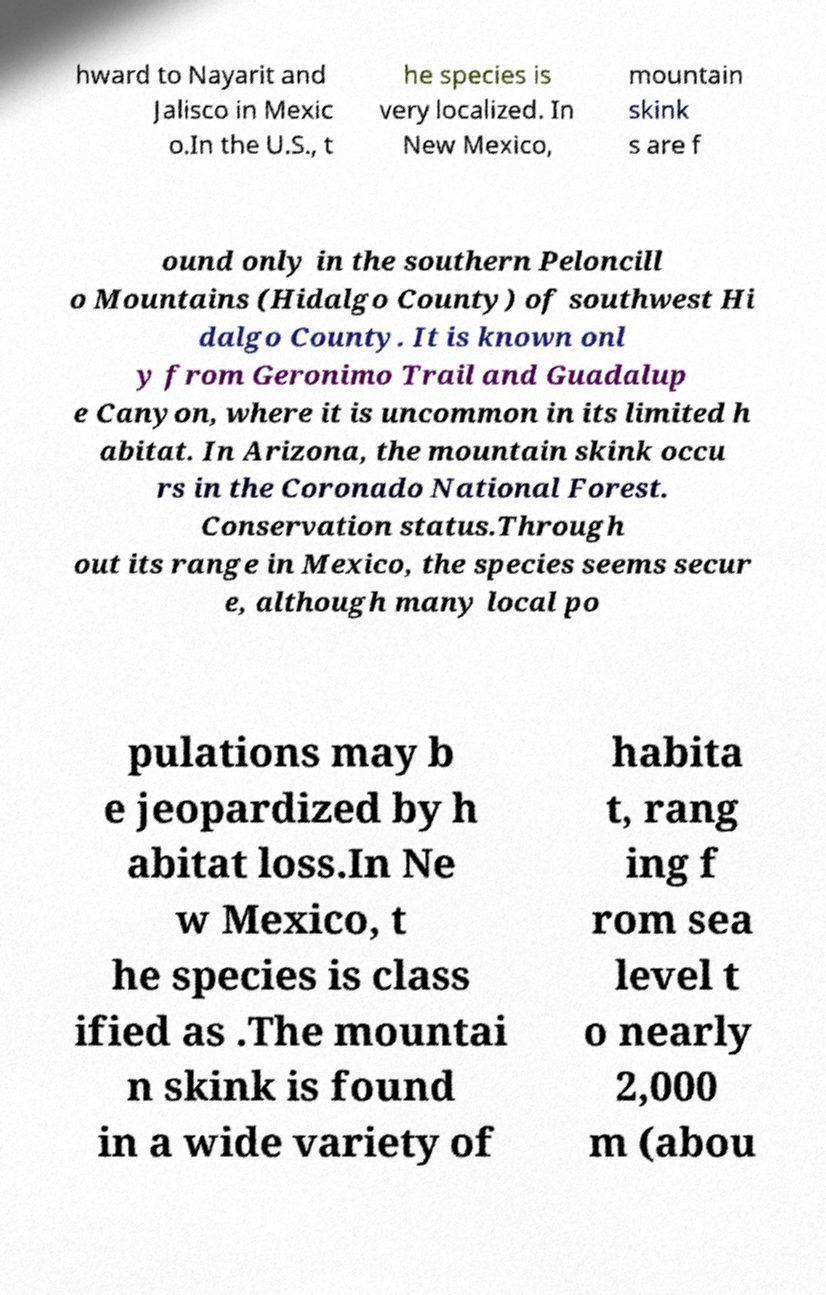Please read and relay the text visible in this image. What does it say? hward to Nayarit and Jalisco in Mexic o.In the U.S., t he species is very localized. In New Mexico, mountain skink s are f ound only in the southern Peloncill o Mountains (Hidalgo County) of southwest Hi dalgo County. It is known onl y from Geronimo Trail and Guadalup e Canyon, where it is uncommon in its limited h abitat. In Arizona, the mountain skink occu rs in the Coronado National Forest. Conservation status.Through out its range in Mexico, the species seems secur e, although many local po pulations may b e jeopardized by h abitat loss.In Ne w Mexico, t he species is class ified as .The mountai n skink is found in a wide variety of habita t, rang ing f rom sea level t o nearly 2,000 m (abou 